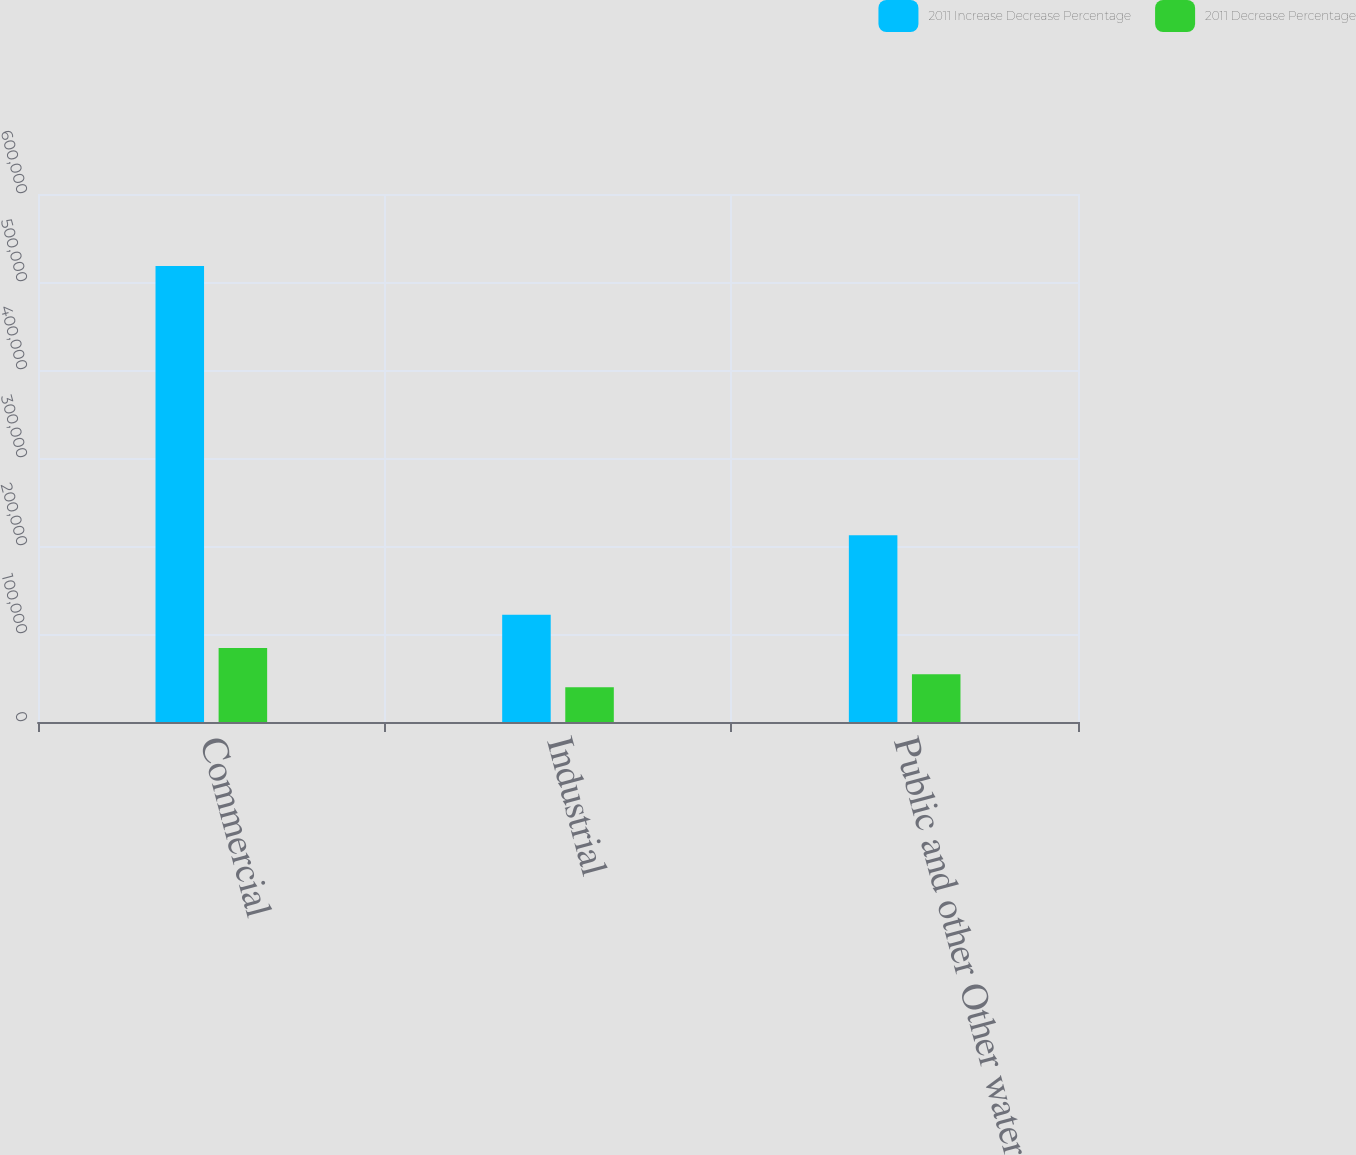Convert chart. <chart><loc_0><loc_0><loc_500><loc_500><stacked_bar_chart><ecel><fcel>Commercial<fcel>Industrial<fcel>Public and other Other water<nl><fcel>2011 Increase Decrease Percentage<fcel>518253<fcel>121902<fcel>212289<nl><fcel>2011 Decrease Percentage<fcel>84226<fcel>39429<fcel>54202<nl></chart> 